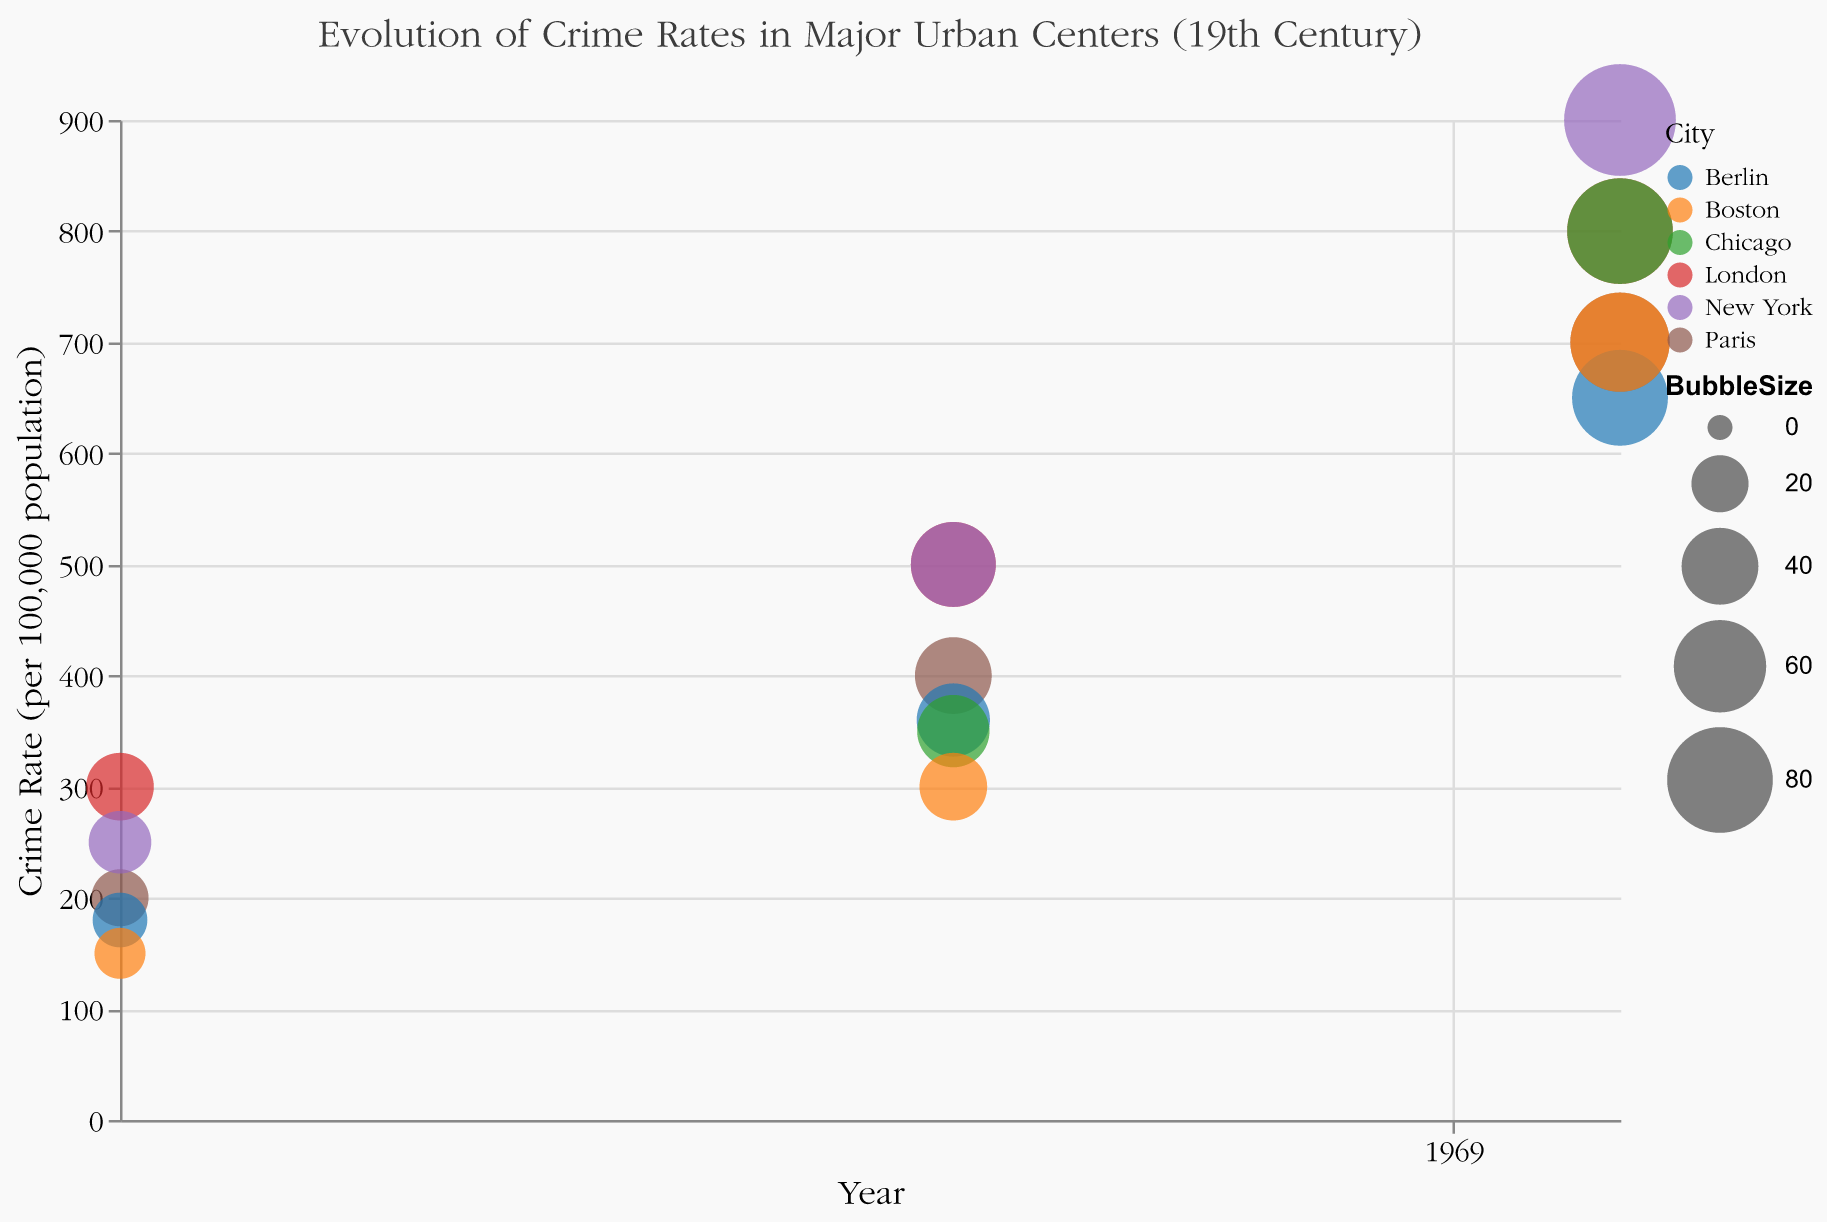What city had the highest crime rate in 1890? From the graph, we see that New York had the largest bubble in 1890 with a crime rate of 900.
Answer: New York What is the title of the figure? The title is displayed at the top center of the figure.
Answer: Evolution of Crime Rates in Major Urban Centers (19th Century) Which city showed the largest increase in theft crime rate from 1800 to 1890? By analyzing the theft crime rates, London went from 300 in 1800 to 800 in 1890, which is an increase of 500.
Answer: London How did the crime rate in Paris change from 1850 to 1890? The crime rate in Paris increased from 400 to 700 from 1850 to 1890.
Answer: Increased by 300 What color represents New York in the chart? By looking at the legend, New York is represented by a specific color.
Answer: New York is represented by a specific color (answering designs like "blue" or "red" will depend on the actual figure) What year did Berlin have a crime rate of 360? By finding Berlin's bubble with a crime rate of 360, it lines up with the year 1850 on the x-axis.
Answer: 1850 Compare the bubble sizes of London and Paris in 1850. Which is larger and what does it signify? The bubble for London in 1850 is larger than that of Paris and since bubble size represents the population, London had a larger population.
Answer: London's bubble is larger, indicating a larger population What type of crime had the highest recorded rate in New York in 1850? By hovering or referring to the tooltip on New York's bubble in 1850, it shows as "Murder."
Answer: Murder What was the population of Boston in 1800? By referring to the tooltip for Boston's 1800 bubble, it shows a population of 200,000.
Answer: 200,000 How did the crime type for Chicago in 1850 compare to Boston's in 1850? By examining the crime types for each city in 1850, Chicago's is "Robbery" and Boston's is "Assault."
Answer: Robbery vs Assault 